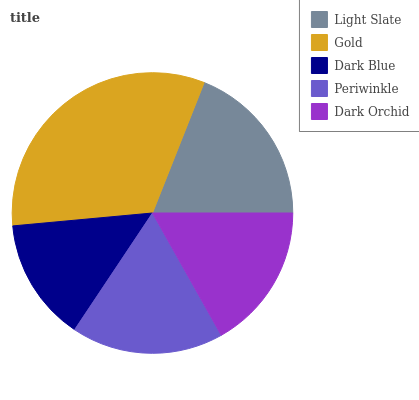Is Dark Blue the minimum?
Answer yes or no. Yes. Is Gold the maximum?
Answer yes or no. Yes. Is Gold the minimum?
Answer yes or no. No. Is Dark Blue the maximum?
Answer yes or no. No. Is Gold greater than Dark Blue?
Answer yes or no. Yes. Is Dark Blue less than Gold?
Answer yes or no. Yes. Is Dark Blue greater than Gold?
Answer yes or no. No. Is Gold less than Dark Blue?
Answer yes or no. No. Is Periwinkle the high median?
Answer yes or no. Yes. Is Periwinkle the low median?
Answer yes or no. Yes. Is Light Slate the high median?
Answer yes or no. No. Is Dark Blue the low median?
Answer yes or no. No. 